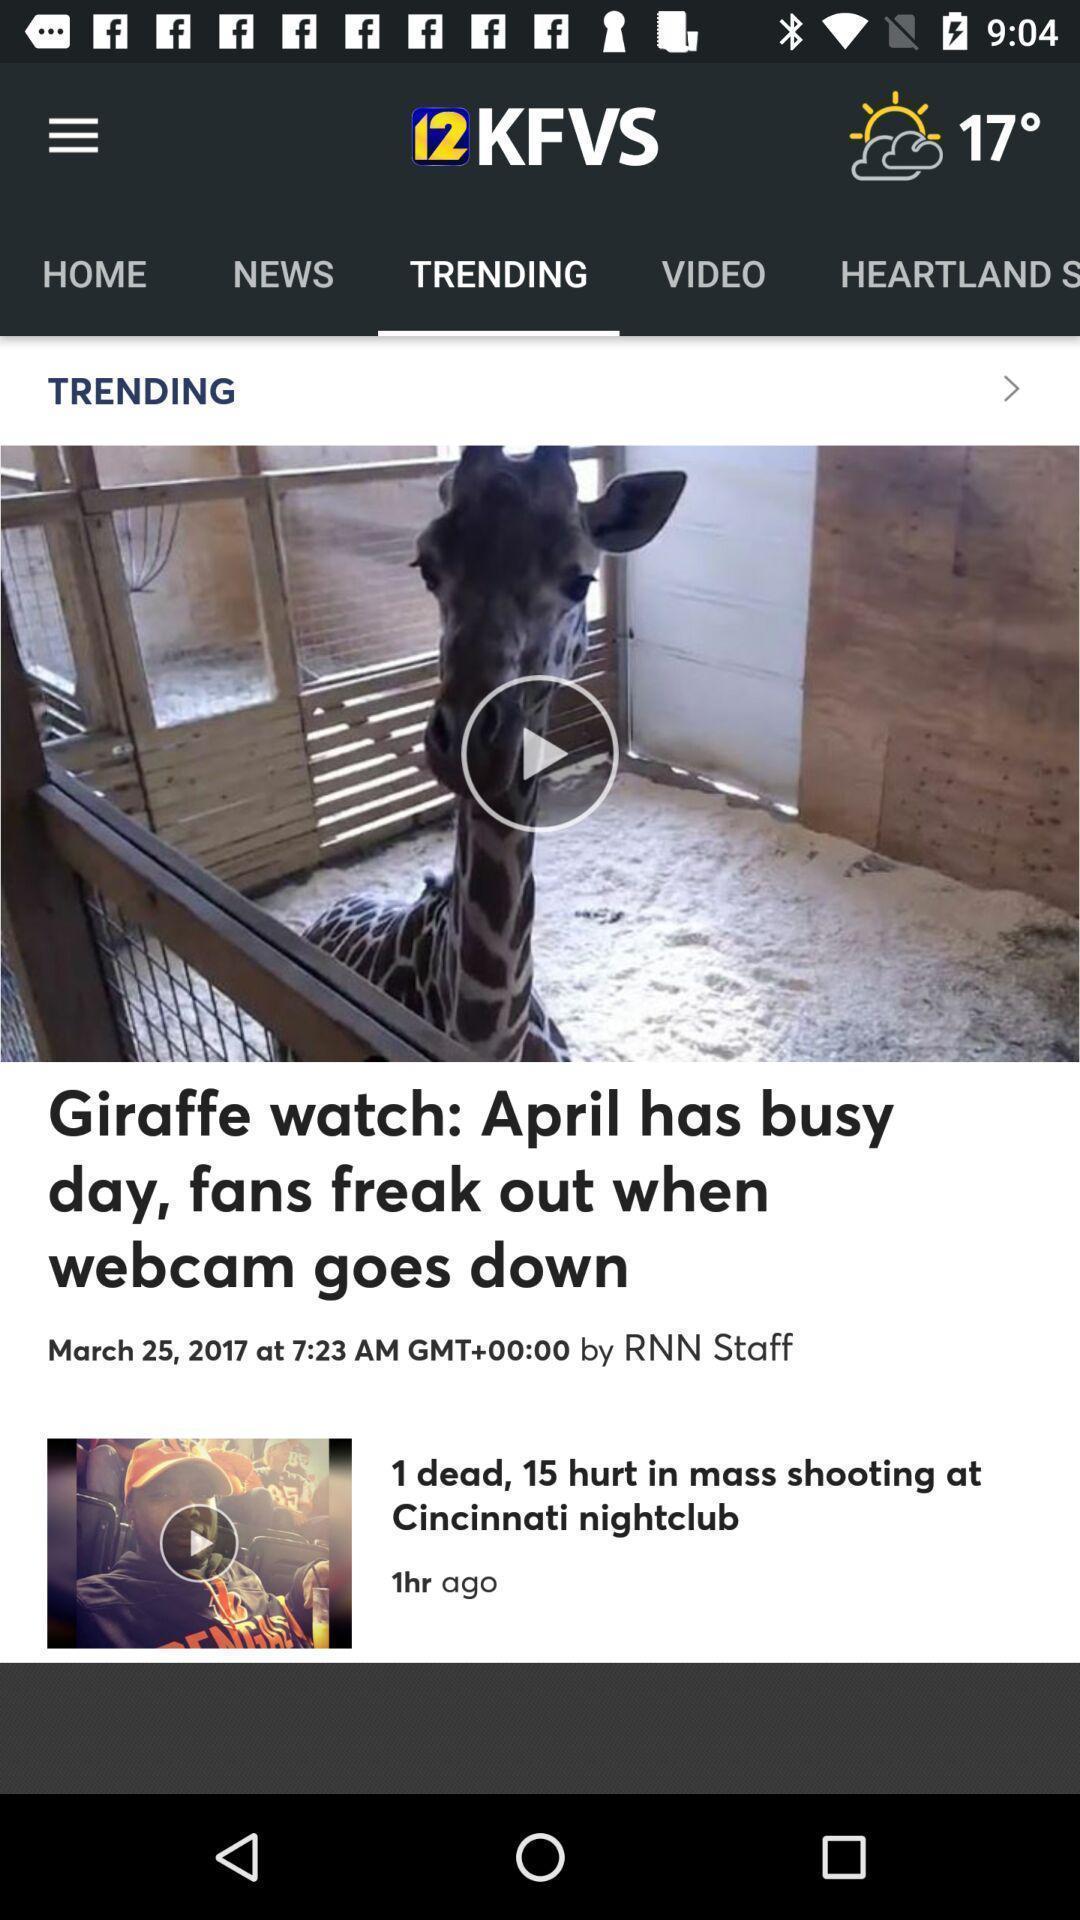Tell me about the visual elements in this screen capture. Trending page displaying in news application. 